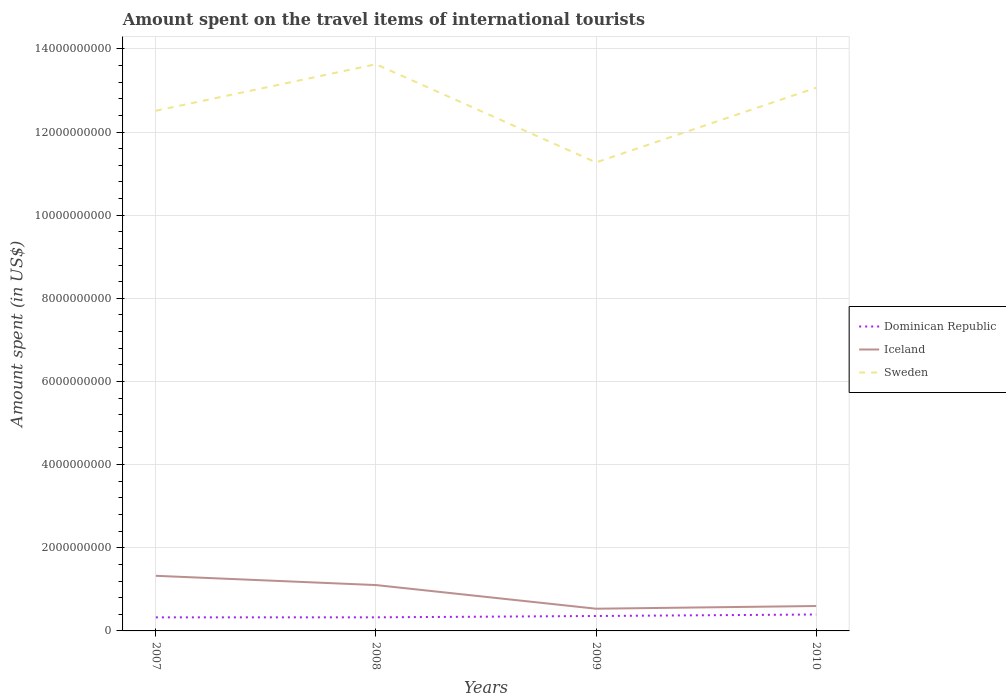How many different coloured lines are there?
Offer a very short reply. 3. Is the number of lines equal to the number of legend labels?
Give a very brief answer. Yes. Across all years, what is the maximum amount spent on the travel items of international tourists in Iceland?
Your answer should be very brief. 5.34e+08. In which year was the amount spent on the travel items of international tourists in Dominican Republic maximum?
Provide a succinct answer. 2007. What is the total amount spent on the travel items of international tourists in Dominican Republic in the graph?
Your answer should be very brief. -3.20e+07. What is the difference between the highest and the second highest amount spent on the travel items of international tourists in Dominican Republic?
Your answer should be very brief. 6.90e+07. How many years are there in the graph?
Keep it short and to the point. 4. What is the difference between two consecutive major ticks on the Y-axis?
Your answer should be very brief. 2.00e+09. Does the graph contain grids?
Your answer should be very brief. Yes. What is the title of the graph?
Provide a succinct answer. Amount spent on the travel items of international tourists. Does "Tanzania" appear as one of the legend labels in the graph?
Offer a very short reply. No. What is the label or title of the Y-axis?
Give a very brief answer. Amount spent (in US$). What is the Amount spent (in US$) in Dominican Republic in 2007?
Your answer should be compact. 3.26e+08. What is the Amount spent (in US$) of Iceland in 2007?
Make the answer very short. 1.33e+09. What is the Amount spent (in US$) of Sweden in 2007?
Your answer should be very brief. 1.25e+1. What is the Amount spent (in US$) in Dominican Republic in 2008?
Your answer should be compact. 3.27e+08. What is the Amount spent (in US$) in Iceland in 2008?
Offer a very short reply. 1.10e+09. What is the Amount spent (in US$) of Sweden in 2008?
Give a very brief answer. 1.36e+1. What is the Amount spent (in US$) in Dominican Republic in 2009?
Offer a terse response. 3.59e+08. What is the Amount spent (in US$) of Iceland in 2009?
Give a very brief answer. 5.34e+08. What is the Amount spent (in US$) of Sweden in 2009?
Provide a short and direct response. 1.13e+1. What is the Amount spent (in US$) in Dominican Republic in 2010?
Give a very brief answer. 3.95e+08. What is the Amount spent (in US$) of Iceland in 2010?
Make the answer very short. 5.99e+08. What is the Amount spent (in US$) in Sweden in 2010?
Your answer should be compact. 1.31e+1. Across all years, what is the maximum Amount spent (in US$) in Dominican Republic?
Make the answer very short. 3.95e+08. Across all years, what is the maximum Amount spent (in US$) in Iceland?
Provide a short and direct response. 1.33e+09. Across all years, what is the maximum Amount spent (in US$) in Sweden?
Offer a very short reply. 1.36e+1. Across all years, what is the minimum Amount spent (in US$) of Dominican Republic?
Offer a very short reply. 3.26e+08. Across all years, what is the minimum Amount spent (in US$) of Iceland?
Offer a very short reply. 5.34e+08. Across all years, what is the minimum Amount spent (in US$) of Sweden?
Provide a short and direct response. 1.13e+1. What is the total Amount spent (in US$) in Dominican Republic in the graph?
Give a very brief answer. 1.41e+09. What is the total Amount spent (in US$) of Iceland in the graph?
Ensure brevity in your answer.  3.56e+09. What is the total Amount spent (in US$) in Sweden in the graph?
Offer a very short reply. 5.05e+1. What is the difference between the Amount spent (in US$) of Iceland in 2007 and that in 2008?
Your answer should be very brief. 2.23e+08. What is the difference between the Amount spent (in US$) of Sweden in 2007 and that in 2008?
Make the answer very short. -1.12e+09. What is the difference between the Amount spent (in US$) of Dominican Republic in 2007 and that in 2009?
Ensure brevity in your answer.  -3.30e+07. What is the difference between the Amount spent (in US$) in Iceland in 2007 and that in 2009?
Make the answer very short. 7.92e+08. What is the difference between the Amount spent (in US$) of Sweden in 2007 and that in 2009?
Give a very brief answer. 1.24e+09. What is the difference between the Amount spent (in US$) of Dominican Republic in 2007 and that in 2010?
Give a very brief answer. -6.90e+07. What is the difference between the Amount spent (in US$) in Iceland in 2007 and that in 2010?
Keep it short and to the point. 7.27e+08. What is the difference between the Amount spent (in US$) of Sweden in 2007 and that in 2010?
Your answer should be very brief. -5.53e+08. What is the difference between the Amount spent (in US$) of Dominican Republic in 2008 and that in 2009?
Provide a short and direct response. -3.20e+07. What is the difference between the Amount spent (in US$) in Iceland in 2008 and that in 2009?
Offer a terse response. 5.69e+08. What is the difference between the Amount spent (in US$) in Sweden in 2008 and that in 2009?
Your answer should be very brief. 2.36e+09. What is the difference between the Amount spent (in US$) in Dominican Republic in 2008 and that in 2010?
Provide a short and direct response. -6.80e+07. What is the difference between the Amount spent (in US$) in Iceland in 2008 and that in 2010?
Your response must be concise. 5.04e+08. What is the difference between the Amount spent (in US$) in Sweden in 2008 and that in 2010?
Offer a terse response. 5.65e+08. What is the difference between the Amount spent (in US$) of Dominican Republic in 2009 and that in 2010?
Provide a short and direct response. -3.60e+07. What is the difference between the Amount spent (in US$) of Iceland in 2009 and that in 2010?
Give a very brief answer. -6.50e+07. What is the difference between the Amount spent (in US$) of Sweden in 2009 and that in 2010?
Provide a short and direct response. -1.80e+09. What is the difference between the Amount spent (in US$) in Dominican Republic in 2007 and the Amount spent (in US$) in Iceland in 2008?
Give a very brief answer. -7.77e+08. What is the difference between the Amount spent (in US$) in Dominican Republic in 2007 and the Amount spent (in US$) in Sweden in 2008?
Your response must be concise. -1.33e+1. What is the difference between the Amount spent (in US$) in Iceland in 2007 and the Amount spent (in US$) in Sweden in 2008?
Offer a terse response. -1.23e+1. What is the difference between the Amount spent (in US$) in Dominican Republic in 2007 and the Amount spent (in US$) in Iceland in 2009?
Ensure brevity in your answer.  -2.08e+08. What is the difference between the Amount spent (in US$) of Dominican Republic in 2007 and the Amount spent (in US$) of Sweden in 2009?
Give a very brief answer. -1.09e+1. What is the difference between the Amount spent (in US$) of Iceland in 2007 and the Amount spent (in US$) of Sweden in 2009?
Offer a terse response. -9.94e+09. What is the difference between the Amount spent (in US$) of Dominican Republic in 2007 and the Amount spent (in US$) of Iceland in 2010?
Keep it short and to the point. -2.73e+08. What is the difference between the Amount spent (in US$) in Dominican Republic in 2007 and the Amount spent (in US$) in Sweden in 2010?
Give a very brief answer. -1.27e+1. What is the difference between the Amount spent (in US$) in Iceland in 2007 and the Amount spent (in US$) in Sweden in 2010?
Provide a succinct answer. -1.17e+1. What is the difference between the Amount spent (in US$) of Dominican Republic in 2008 and the Amount spent (in US$) of Iceland in 2009?
Ensure brevity in your answer.  -2.07e+08. What is the difference between the Amount spent (in US$) in Dominican Republic in 2008 and the Amount spent (in US$) in Sweden in 2009?
Provide a short and direct response. -1.09e+1. What is the difference between the Amount spent (in US$) of Iceland in 2008 and the Amount spent (in US$) of Sweden in 2009?
Ensure brevity in your answer.  -1.02e+1. What is the difference between the Amount spent (in US$) of Dominican Republic in 2008 and the Amount spent (in US$) of Iceland in 2010?
Keep it short and to the point. -2.72e+08. What is the difference between the Amount spent (in US$) in Dominican Republic in 2008 and the Amount spent (in US$) in Sweden in 2010?
Your answer should be compact. -1.27e+1. What is the difference between the Amount spent (in US$) of Iceland in 2008 and the Amount spent (in US$) of Sweden in 2010?
Keep it short and to the point. -1.20e+1. What is the difference between the Amount spent (in US$) of Dominican Republic in 2009 and the Amount spent (in US$) of Iceland in 2010?
Give a very brief answer. -2.40e+08. What is the difference between the Amount spent (in US$) in Dominican Republic in 2009 and the Amount spent (in US$) in Sweden in 2010?
Keep it short and to the point. -1.27e+1. What is the difference between the Amount spent (in US$) of Iceland in 2009 and the Amount spent (in US$) of Sweden in 2010?
Provide a succinct answer. -1.25e+1. What is the average Amount spent (in US$) of Dominican Republic per year?
Ensure brevity in your answer.  3.52e+08. What is the average Amount spent (in US$) in Iceland per year?
Provide a succinct answer. 8.90e+08. What is the average Amount spent (in US$) of Sweden per year?
Your answer should be compact. 1.26e+1. In the year 2007, what is the difference between the Amount spent (in US$) of Dominican Republic and Amount spent (in US$) of Iceland?
Ensure brevity in your answer.  -1.00e+09. In the year 2007, what is the difference between the Amount spent (in US$) of Dominican Republic and Amount spent (in US$) of Sweden?
Offer a terse response. -1.22e+1. In the year 2007, what is the difference between the Amount spent (in US$) of Iceland and Amount spent (in US$) of Sweden?
Keep it short and to the point. -1.12e+1. In the year 2008, what is the difference between the Amount spent (in US$) of Dominican Republic and Amount spent (in US$) of Iceland?
Provide a succinct answer. -7.76e+08. In the year 2008, what is the difference between the Amount spent (in US$) in Dominican Republic and Amount spent (in US$) in Sweden?
Offer a terse response. -1.33e+1. In the year 2008, what is the difference between the Amount spent (in US$) in Iceland and Amount spent (in US$) in Sweden?
Provide a short and direct response. -1.25e+1. In the year 2009, what is the difference between the Amount spent (in US$) in Dominican Republic and Amount spent (in US$) in Iceland?
Ensure brevity in your answer.  -1.75e+08. In the year 2009, what is the difference between the Amount spent (in US$) in Dominican Republic and Amount spent (in US$) in Sweden?
Your response must be concise. -1.09e+1. In the year 2009, what is the difference between the Amount spent (in US$) of Iceland and Amount spent (in US$) of Sweden?
Ensure brevity in your answer.  -1.07e+1. In the year 2010, what is the difference between the Amount spent (in US$) of Dominican Republic and Amount spent (in US$) of Iceland?
Provide a succinct answer. -2.04e+08. In the year 2010, what is the difference between the Amount spent (in US$) of Dominican Republic and Amount spent (in US$) of Sweden?
Keep it short and to the point. -1.27e+1. In the year 2010, what is the difference between the Amount spent (in US$) of Iceland and Amount spent (in US$) of Sweden?
Make the answer very short. -1.25e+1. What is the ratio of the Amount spent (in US$) of Iceland in 2007 to that in 2008?
Offer a very short reply. 1.2. What is the ratio of the Amount spent (in US$) of Sweden in 2007 to that in 2008?
Ensure brevity in your answer.  0.92. What is the ratio of the Amount spent (in US$) in Dominican Republic in 2007 to that in 2009?
Your answer should be very brief. 0.91. What is the ratio of the Amount spent (in US$) in Iceland in 2007 to that in 2009?
Offer a terse response. 2.48. What is the ratio of the Amount spent (in US$) of Sweden in 2007 to that in 2009?
Your answer should be very brief. 1.11. What is the ratio of the Amount spent (in US$) of Dominican Republic in 2007 to that in 2010?
Offer a terse response. 0.83. What is the ratio of the Amount spent (in US$) in Iceland in 2007 to that in 2010?
Your answer should be compact. 2.21. What is the ratio of the Amount spent (in US$) in Sweden in 2007 to that in 2010?
Give a very brief answer. 0.96. What is the ratio of the Amount spent (in US$) in Dominican Republic in 2008 to that in 2009?
Ensure brevity in your answer.  0.91. What is the ratio of the Amount spent (in US$) of Iceland in 2008 to that in 2009?
Your response must be concise. 2.07. What is the ratio of the Amount spent (in US$) in Sweden in 2008 to that in 2009?
Ensure brevity in your answer.  1.21. What is the ratio of the Amount spent (in US$) in Dominican Republic in 2008 to that in 2010?
Ensure brevity in your answer.  0.83. What is the ratio of the Amount spent (in US$) in Iceland in 2008 to that in 2010?
Offer a terse response. 1.84. What is the ratio of the Amount spent (in US$) in Sweden in 2008 to that in 2010?
Give a very brief answer. 1.04. What is the ratio of the Amount spent (in US$) in Dominican Republic in 2009 to that in 2010?
Your response must be concise. 0.91. What is the ratio of the Amount spent (in US$) of Iceland in 2009 to that in 2010?
Give a very brief answer. 0.89. What is the ratio of the Amount spent (in US$) of Sweden in 2009 to that in 2010?
Offer a very short reply. 0.86. What is the difference between the highest and the second highest Amount spent (in US$) of Dominican Republic?
Offer a very short reply. 3.60e+07. What is the difference between the highest and the second highest Amount spent (in US$) of Iceland?
Ensure brevity in your answer.  2.23e+08. What is the difference between the highest and the second highest Amount spent (in US$) in Sweden?
Give a very brief answer. 5.65e+08. What is the difference between the highest and the lowest Amount spent (in US$) of Dominican Republic?
Your answer should be compact. 6.90e+07. What is the difference between the highest and the lowest Amount spent (in US$) in Iceland?
Ensure brevity in your answer.  7.92e+08. What is the difference between the highest and the lowest Amount spent (in US$) in Sweden?
Provide a succinct answer. 2.36e+09. 